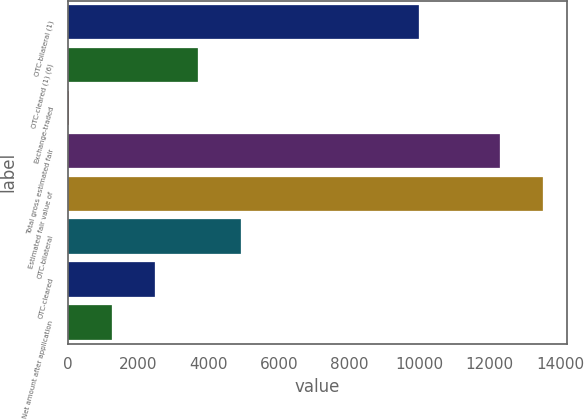Convert chart. <chart><loc_0><loc_0><loc_500><loc_500><bar_chart><fcel>OTC-bilateral (1)<fcel>OTC-cleared (1) (6)<fcel>Exchange-traded<fcel>Total gross estimated fair<fcel>Estimated fair value of<fcel>OTC-bilateral<fcel>OTC-cleared<fcel>Net amount after application<nl><fcel>9976<fcel>3708.3<fcel>33<fcel>12284<fcel>13509.1<fcel>4933.4<fcel>2483.2<fcel>1258.1<nl></chart> 